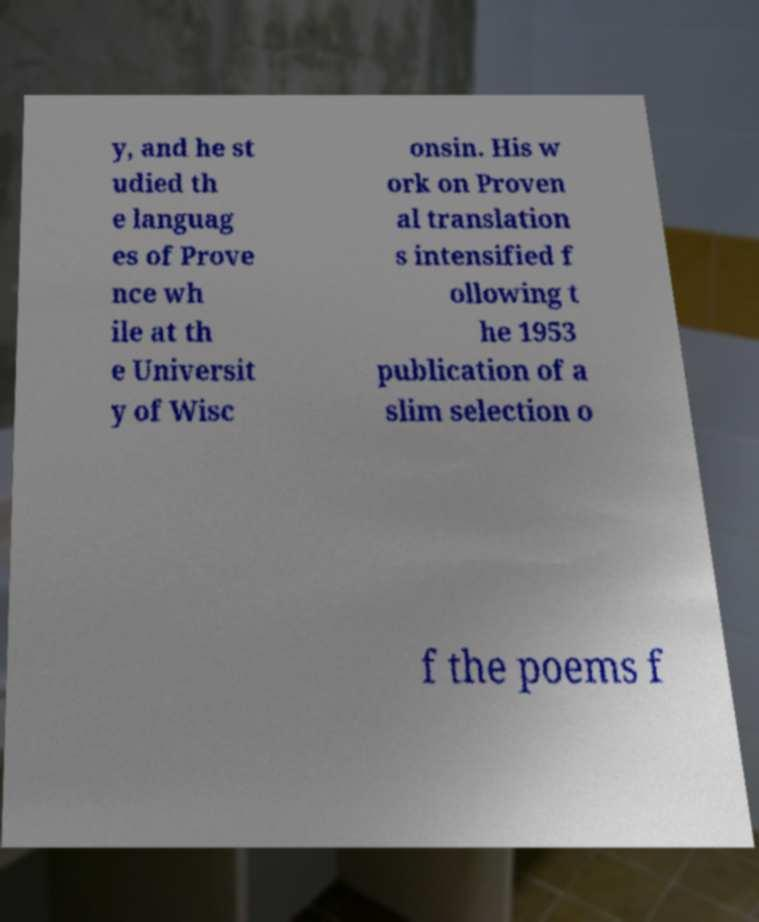I need the written content from this picture converted into text. Can you do that? y, and he st udied th e languag es of Prove nce wh ile at th e Universit y of Wisc onsin. His w ork on Proven al translation s intensified f ollowing t he 1953 publication of a slim selection o f the poems f 